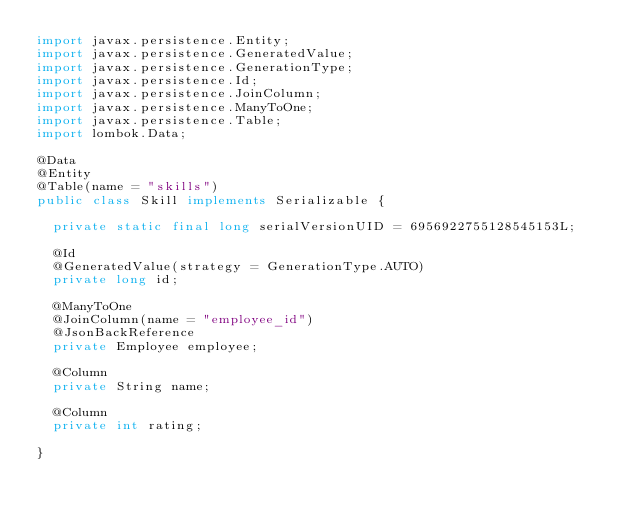Convert code to text. <code><loc_0><loc_0><loc_500><loc_500><_Java_>import javax.persistence.Entity;
import javax.persistence.GeneratedValue;
import javax.persistence.GenerationType;
import javax.persistence.Id;
import javax.persistence.JoinColumn;
import javax.persistence.ManyToOne;
import javax.persistence.Table;
import lombok.Data;

@Data
@Entity
@Table(name = "skills")
public class Skill implements Serializable {

  private static final long serialVersionUID = 6956922755128545153L;

  @Id
  @GeneratedValue(strategy = GenerationType.AUTO)
  private long id;

  @ManyToOne
  @JoinColumn(name = "employee_id")
  @JsonBackReference
  private Employee employee;

  @Column
  private String name;

  @Column
  private int rating;

}
</code> 